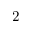Convert formula to latex. <formula><loc_0><loc_0><loc_500><loc_500>2</formula> 